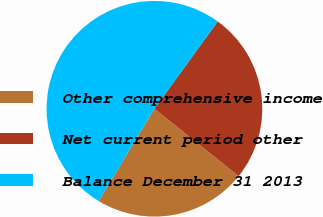Convert chart to OTSL. <chart><loc_0><loc_0><loc_500><loc_500><pie_chart><fcel>Other comprehensive income<fcel>Net current period other<fcel>Balance December 31 2013<nl><fcel>22.92%<fcel>25.76%<fcel>51.32%<nl></chart> 